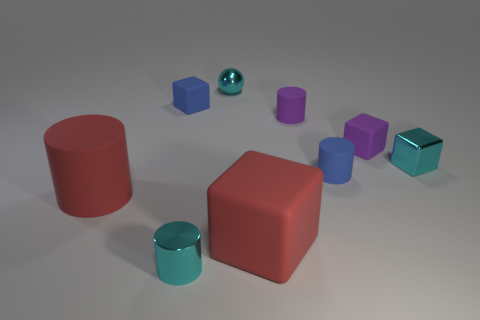Add 1 tiny matte objects. How many objects exist? 10 Subtract all cubes. How many objects are left? 5 Add 2 tiny blue rubber cubes. How many tiny blue rubber cubes are left? 3 Add 2 shiny cubes. How many shiny cubes exist? 3 Subtract 0 brown balls. How many objects are left? 9 Subtract all gray matte spheres. Subtract all small purple matte cylinders. How many objects are left? 8 